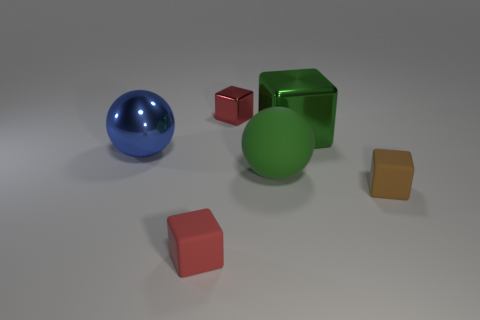Subtract 1 cubes. How many cubes are left? 3 Subtract all blue cubes. Subtract all gray cylinders. How many cubes are left? 4 Add 2 big metal balls. How many objects exist? 8 Subtract all cubes. How many objects are left? 2 Add 2 large green matte objects. How many large green matte objects exist? 3 Subtract 0 yellow cubes. How many objects are left? 6 Subtract all gray metallic blocks. Subtract all blue balls. How many objects are left? 5 Add 5 tiny brown objects. How many tiny brown objects are left? 6 